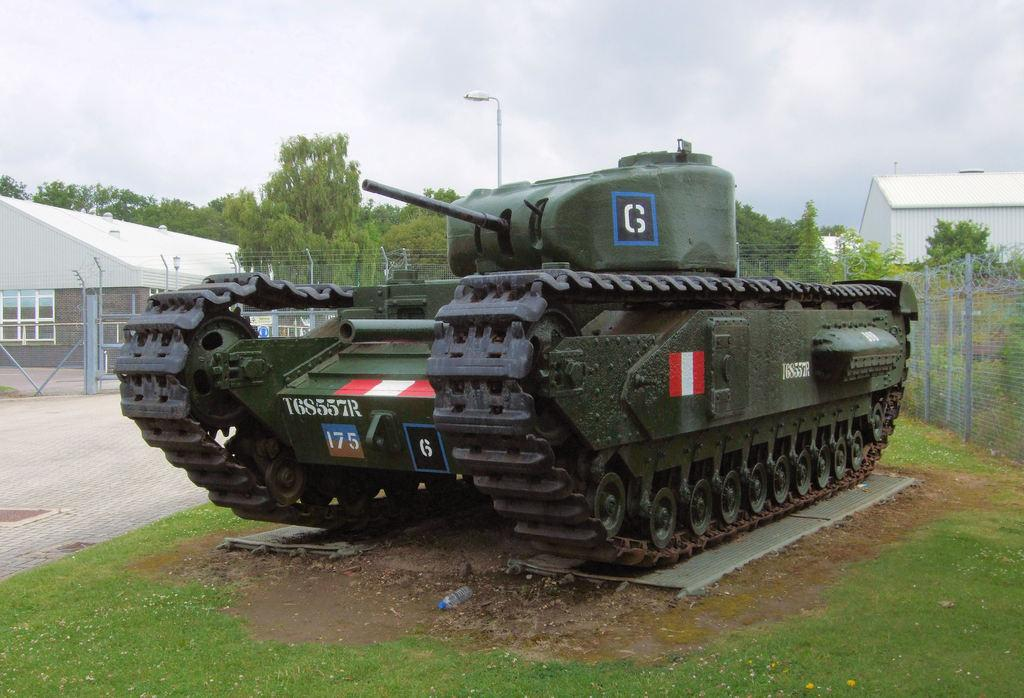What is the main subject in the center of the image? There is a military tank in the center of the image. Where is the military tank located? The military tank is on the floor. What can be seen in the background of the image? In the background of the image, there is fencing, buildings, a light pole, trees, plants, and the sky. How does the military tank contribute to harmony in the image? The image does not depict harmony or any related concept; it simply shows a military tank on the floor with various background elements. --- Facts: 1. There is a person sitting on a chair in the image. 2. The person is holding a book. 3. There is a table next to the chair. 4. There is a lamp on the table. 5. The background of the image is a room. Absurd Topics: ocean, elephant, volcano Conversation: What is the person in the image doing? The person is sitting on a chair in the image. What is the person holding? The person is holding a book. What is located next to the chair? There is a table next to the chair. What is on the table? There is a lamp on the table. What is the setting of the image? The background of the image is a room. Reasoning: Let's think step by step in order to produce the conversation. We start by identifying the main subject in the image, which is the person sitting on a chair. Then, we describe what the person is holding, which is a book. Next, we mention the presence of a table next to the chair and a lamp on the table. Finally, we describe the setting of the image, which is a room. Each question is designed to elicit a specific detail about the image that is known from the provided facts. Absurd Question/Answer: Can you see any elephants or volcanoes in the image? No, there are no elephants or volcanoes present in the image. 